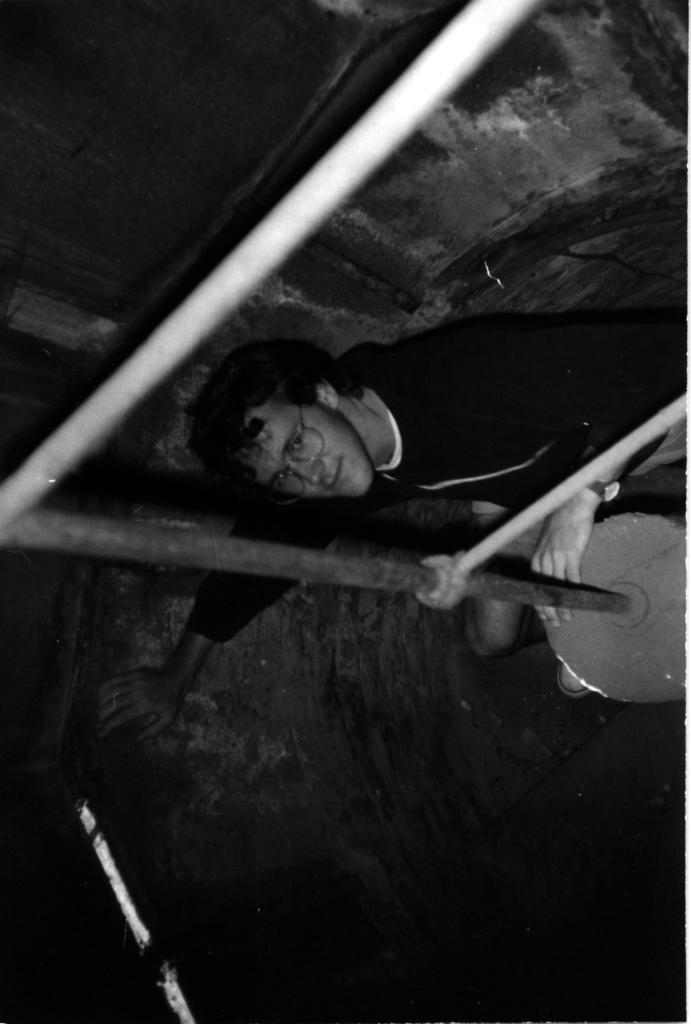What type of image is present in the image? There is a black and white photograph in the image. What is the main subject of the photograph? The photograph depicts a boy sitting on the ground. What is the boy holding in the photograph? The boy is holding a pipe machine. What can be seen in the background of the photograph? There is a big wall in the background of the photograph. What team does the boy support in the photograph? There is no indication of a team or any sports-related activity in the photograph. 